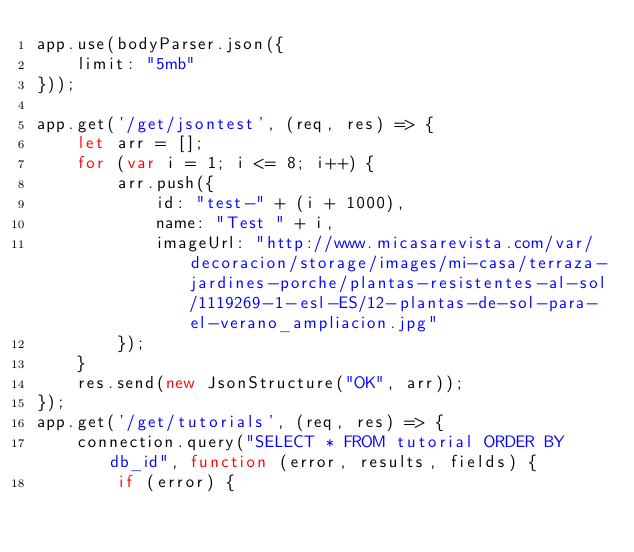Convert code to text. <code><loc_0><loc_0><loc_500><loc_500><_JavaScript_>app.use(bodyParser.json({
    limit: "5mb"
}));

app.get('/get/jsontest', (req, res) => {
    let arr = [];
    for (var i = 1; i <= 8; i++) {
        arr.push({
            id: "test-" + (i + 1000),
            name: "Test " + i,
            imageUrl: "http://www.micasarevista.com/var/decoracion/storage/images/mi-casa/terraza-jardines-porche/plantas-resistentes-al-sol/1119269-1-esl-ES/12-plantas-de-sol-para-el-verano_ampliacion.jpg"
        });
    }
    res.send(new JsonStructure("OK", arr));
});
app.get('/get/tutorials', (req, res) => {
    connection.query("SELECT * FROM tutorial ORDER BY db_id", function (error, results, fields) {
        if (error) {</code> 